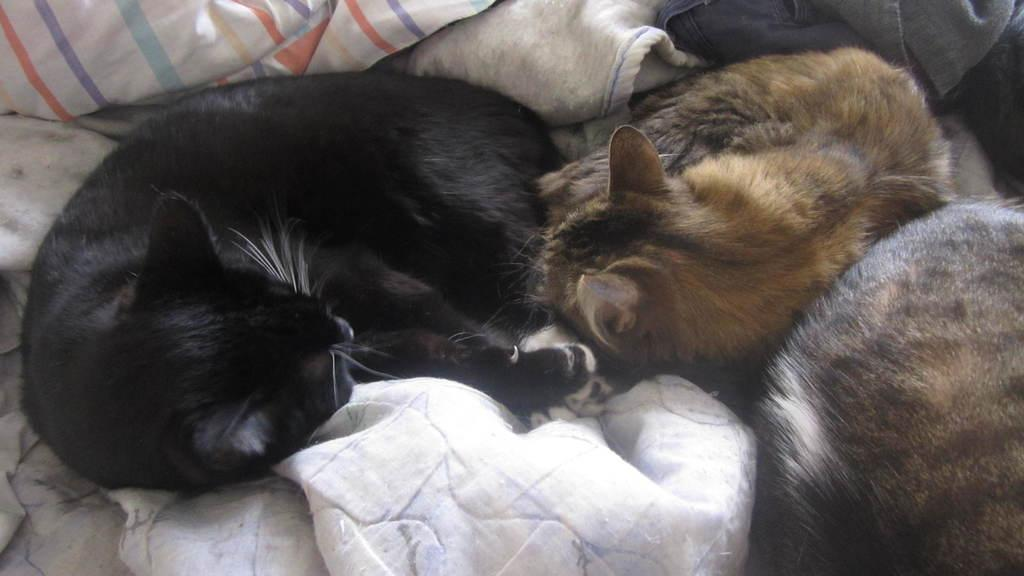What animals are lying in the center of the image? There are cats lying in the center of the image. What else can be seen in the background of the image? There are clothes visible in the background of the image. How many rings are the cats wearing on their tails in the image? There are no rings visible on the cats' tails in the image. What time of day is depicted in the image? The time of day is not indicated in the image. 